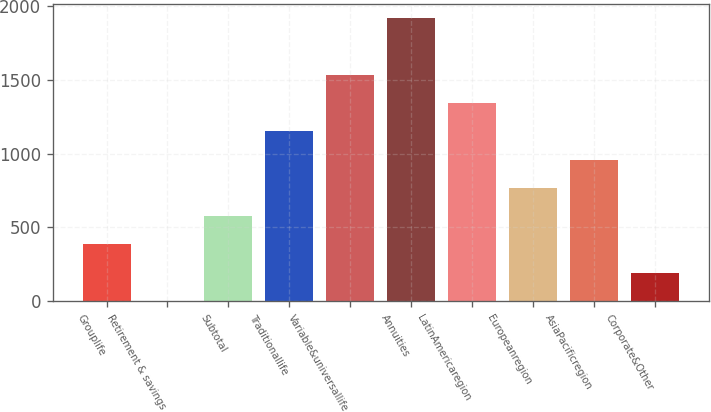<chart> <loc_0><loc_0><loc_500><loc_500><bar_chart><fcel>Grouplife<fcel>Retirement & savings<fcel>Subtotal<fcel>Traditionallife<fcel>Variable&universallife<fcel>Annuities<fcel>LatinAmericaregion<fcel>Europeanregion<fcel>AsiaPacificregion<fcel>Corporate&Other<nl><fcel>384.2<fcel>1<fcel>575.8<fcel>1150.6<fcel>1533.8<fcel>1917<fcel>1342.2<fcel>767.4<fcel>959<fcel>192.6<nl></chart> 